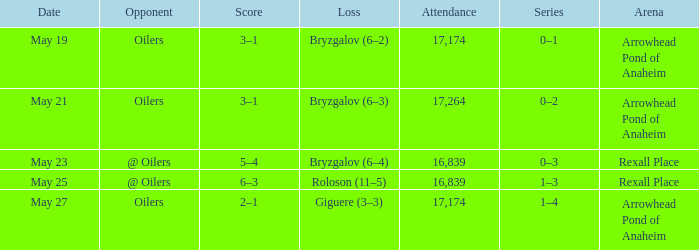Which Arena has an Opponent of @ oilers, and a Date of may 25? Rexall Place. 